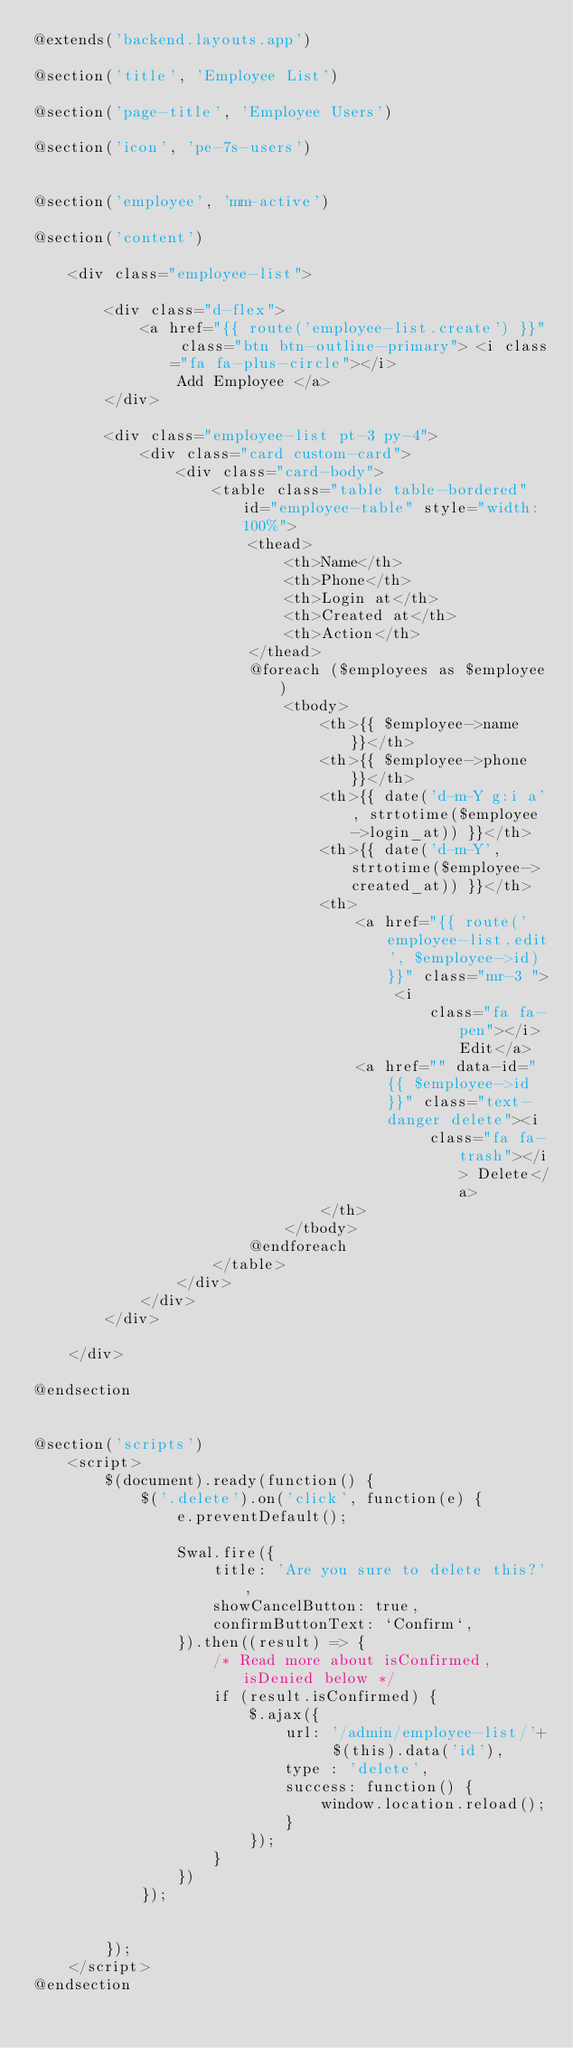<code> <loc_0><loc_0><loc_500><loc_500><_PHP_>@extends('backend.layouts.app')

@section('title', 'Employee List')

@section('page-title', 'Employee Users')

@section('icon', 'pe-7s-users')


@section('employee', 'mm-active')

@section('content')

    <div class="employee-list">

        <div class="d-flex">
            <a href="{{ route('employee-list.create') }}" class="btn btn-outline-primary"> <i class="fa fa-plus-circle"></i>
                Add Employee </a>
        </div>

        <div class="employee-list pt-3 py-4">
            <div class="card custom-card">
                <div class="card-body">
                    <table class="table table-bordered" id="employee-table" style="width: 100%">
                        <thead>
                            <th>Name</th>
                            <th>Phone</th>
                            <th>Login at</th>
                            <th>Created at</th>
                            <th>Action</th>
                        </thead>
                        @foreach ($employees as $employee)
                            <tbody>
                                <th>{{ $employee->name }}</th>
                                <th>{{ $employee->phone }}</th>
                                <th>{{ date('d-m-Y g:i a', strtotime($employee->login_at)) }}</th>
                                <th>{{ date('d-m-Y', strtotime($employee->created_at)) }}</th>
                                <th>
                                    <a href="{{ route('employee-list.edit', $employee->id) }}" class="mr-3 "> <i
                                            class="fa fa-pen"></i> Edit</a>
                                    <a href="" data-id="{{ $employee->id }}" class="text-danger delete"><i
                                            class="fa fa-trash"></i> Delete</a>
                                </th>
                            </tbody>
                        @endforeach
                    </table>
                </div>
            </div>
        </div>

    </div>

@endsection


@section('scripts')
    <script>
        $(document).ready(function() {
            $('.delete').on('click', function(e) {
                e.preventDefault();

                Swal.fire({
                    title: 'Are you sure to delete this?',
                    showCancelButton: true,
                    confirmButtonText: `Confirm`,
                }).then((result) => {
                    /* Read more about isConfirmed, isDenied below */
                    if (result.isConfirmed) {
                        $.ajax({
                            url: '/admin/employee-list/'+  $(this).data('id'),
                            type : 'delete',
                            success: function() {
                                window.location.reload();
                            }
                        });
                    }
                })
            });


        });
    </script>
@endsection
</code> 